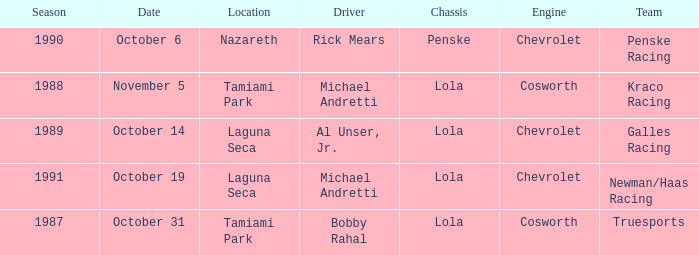On what date was the race at Nazareth? October 6. 